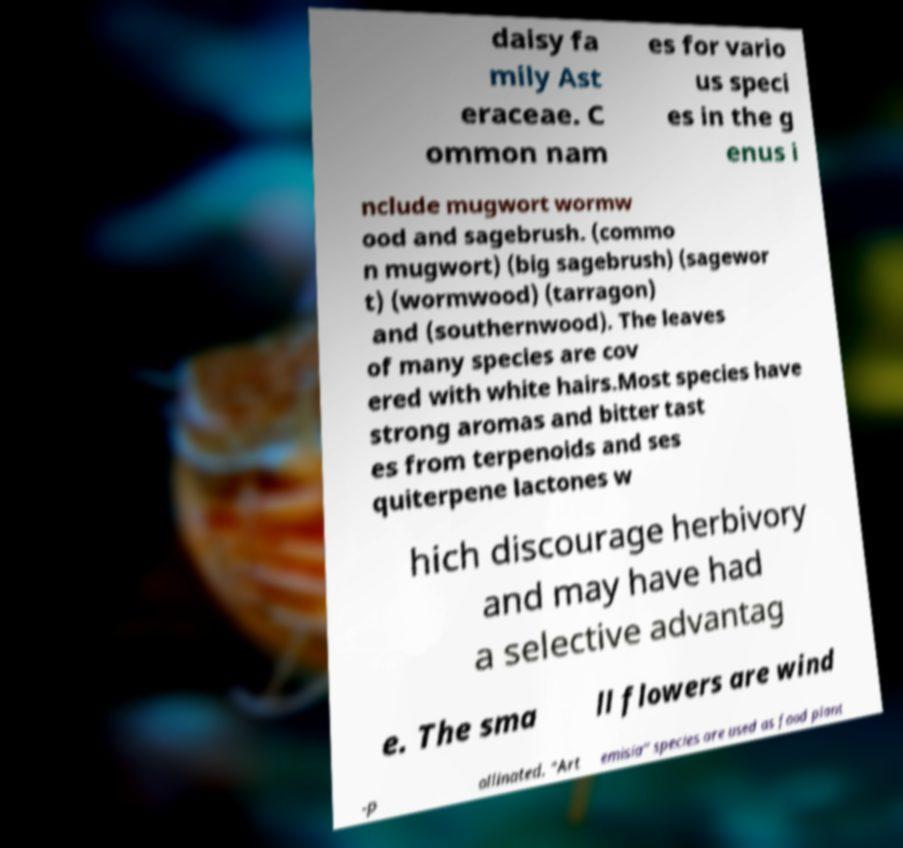I need the written content from this picture converted into text. Can you do that? daisy fa mily Ast eraceae. C ommon nam es for vario us speci es in the g enus i nclude mugwort wormw ood and sagebrush. (commo n mugwort) (big sagebrush) (sagewor t) (wormwood) (tarragon) and (southernwood). The leaves of many species are cov ered with white hairs.Most species have strong aromas and bitter tast es from terpenoids and ses quiterpene lactones w hich discourage herbivory and may have had a selective advantag e. The sma ll flowers are wind -p ollinated. "Art emisia" species are used as food plant 